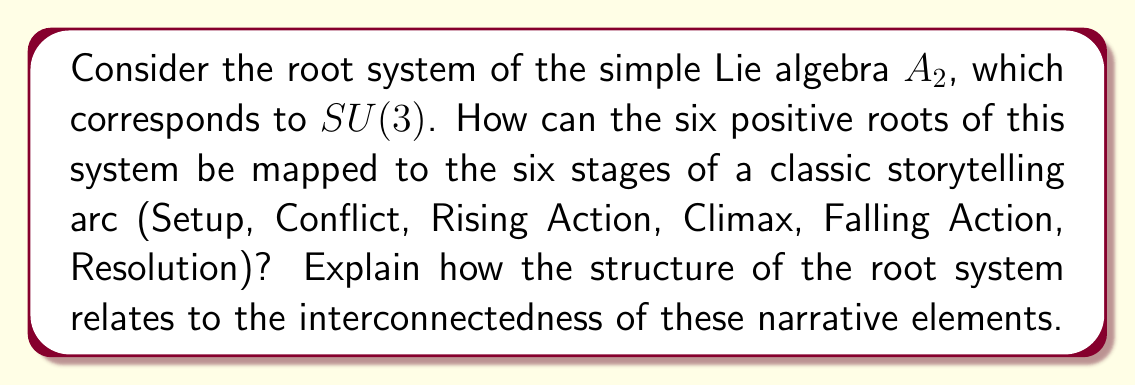Show me your answer to this math problem. To analyze this problem, let's break it down into steps:

1. First, let's recall the root system of $A_2$:
   The positive roots are:
   $\alpha_1 = (1, -1, 0)$
   $\alpha_2 = (0, 1, -1)$
   $\alpha_1 + \alpha_2 = (1, 0, -1)$

   The negative roots are:
   $-\alpha_1 = (-1, 1, 0)$
   $-\alpha_2 = (0, -1, 1)$
   $-(\alpha_1 + \alpha_2) = (-1, 0, 1)$

2. We can represent this root system visually:

   [asy]
   import geometry;
   
   size(200);
   
   pair O=(0,0);
   pair A=(1,-sqrt(3)/3);
   pair B=(0,2*sqrt(3)/3);
   pair C=(-1,-sqrt(3)/3);
   
   draw(O--A,Arrow);
   draw(O--B,Arrow);
   draw(O--C,Arrow);
   draw(O--(-A),Arrow);
   draw(O--(-B),Arrow);
   draw(O--(-C),Arrow);
   
   label("$\alpha_1$",A,E);
   label("$\alpha_2$",B,N);
   label("$\alpha_1+\alpha_2$",C,W);
   label("$-\alpha_1$",-A,W);
   label("$-\alpha_2$",-B,S);
   label("$-(\alpha_1+\alpha_2)$",-C,E);
   
   dot(O);
   [/asy]

3. Now, let's map the six positive roots to the six stages of storytelling:
   - $\alpha_1$ : Setup
   - $\alpha_2$ : Conflict
   - $\alpha_1 + \alpha_2$ : Rising Action
   - $-(\alpha_1 + \alpha_2)$ : Climax
   - $-\alpha_2$ : Falling Action
   - $-\alpha_1$ : Resolution

4. The structure of the root system relates to the interconnectedness of narrative elements:
   a) The simple roots $\alpha_1$ and $\alpha_2$ correspond to Setup and Conflict, the foundational elements of the story.
   b) The sum $\alpha_1 + \alpha_2$ represents Rising Action, showing how the initial elements combine to create tension.
   c) The highest root $-(\alpha_1 + \alpha_2)$ represents the Climax, opposite to the Rising Action.
   d) The negative roots $-\alpha_2$ and $-\alpha_1$ represent Falling Action and Resolution, mirroring the initial elements but in reverse order.

5. The symmetry of the root system reflects the balanced structure of a well-crafted story:
   - The opposite pairs ($\alpha_1$ and $-\alpha_1$, $\alpha_2$ and $-\alpha_2$, $\alpha_1 + \alpha_2$ and $-(\alpha_1 + \alpha_2)$) show how each stage has a corresponding counterpart.
   - The angles between roots (120°) suggest equal importance and interconnectedness of story elements.

6. The closure property of the root system under addition and subtraction mirrors how story elements combine and resolve:
   $\alpha_1 + \alpha_2 = (\alpha_1 + \alpha_2)$ : Setup + Conflict leads to Rising Action
   $(\alpha_1 + \alpha_2) + (-(\alpha_1 + \alpha_2)) = 0$ : Rising Action leads to and is resolved by Climax

This mapping demonstrates how the mathematical structure of the $A_2$ root system can be used as a metaphor for the intricate relationships between different stages of a storytelling arc.
Answer: The six positive roots of the $A_2$ root system can be mapped to the six stages of a classic storytelling arc as follows:

$\alpha_1$ : Setup
$\alpha_2$ : Conflict
$\alpha_1 + \alpha_2$ : Rising Action
$-(\alpha_1 + \alpha_2)$ : Climax
$-\alpha_2$ : Falling Action
$-\alpha_1$ : Resolution

The structure of the root system relates to the interconnectedness of these narrative elements through its symmetry, closure properties, and geometric relationships, reflecting the balanced and interconnected nature of a well-crafted story arc. 